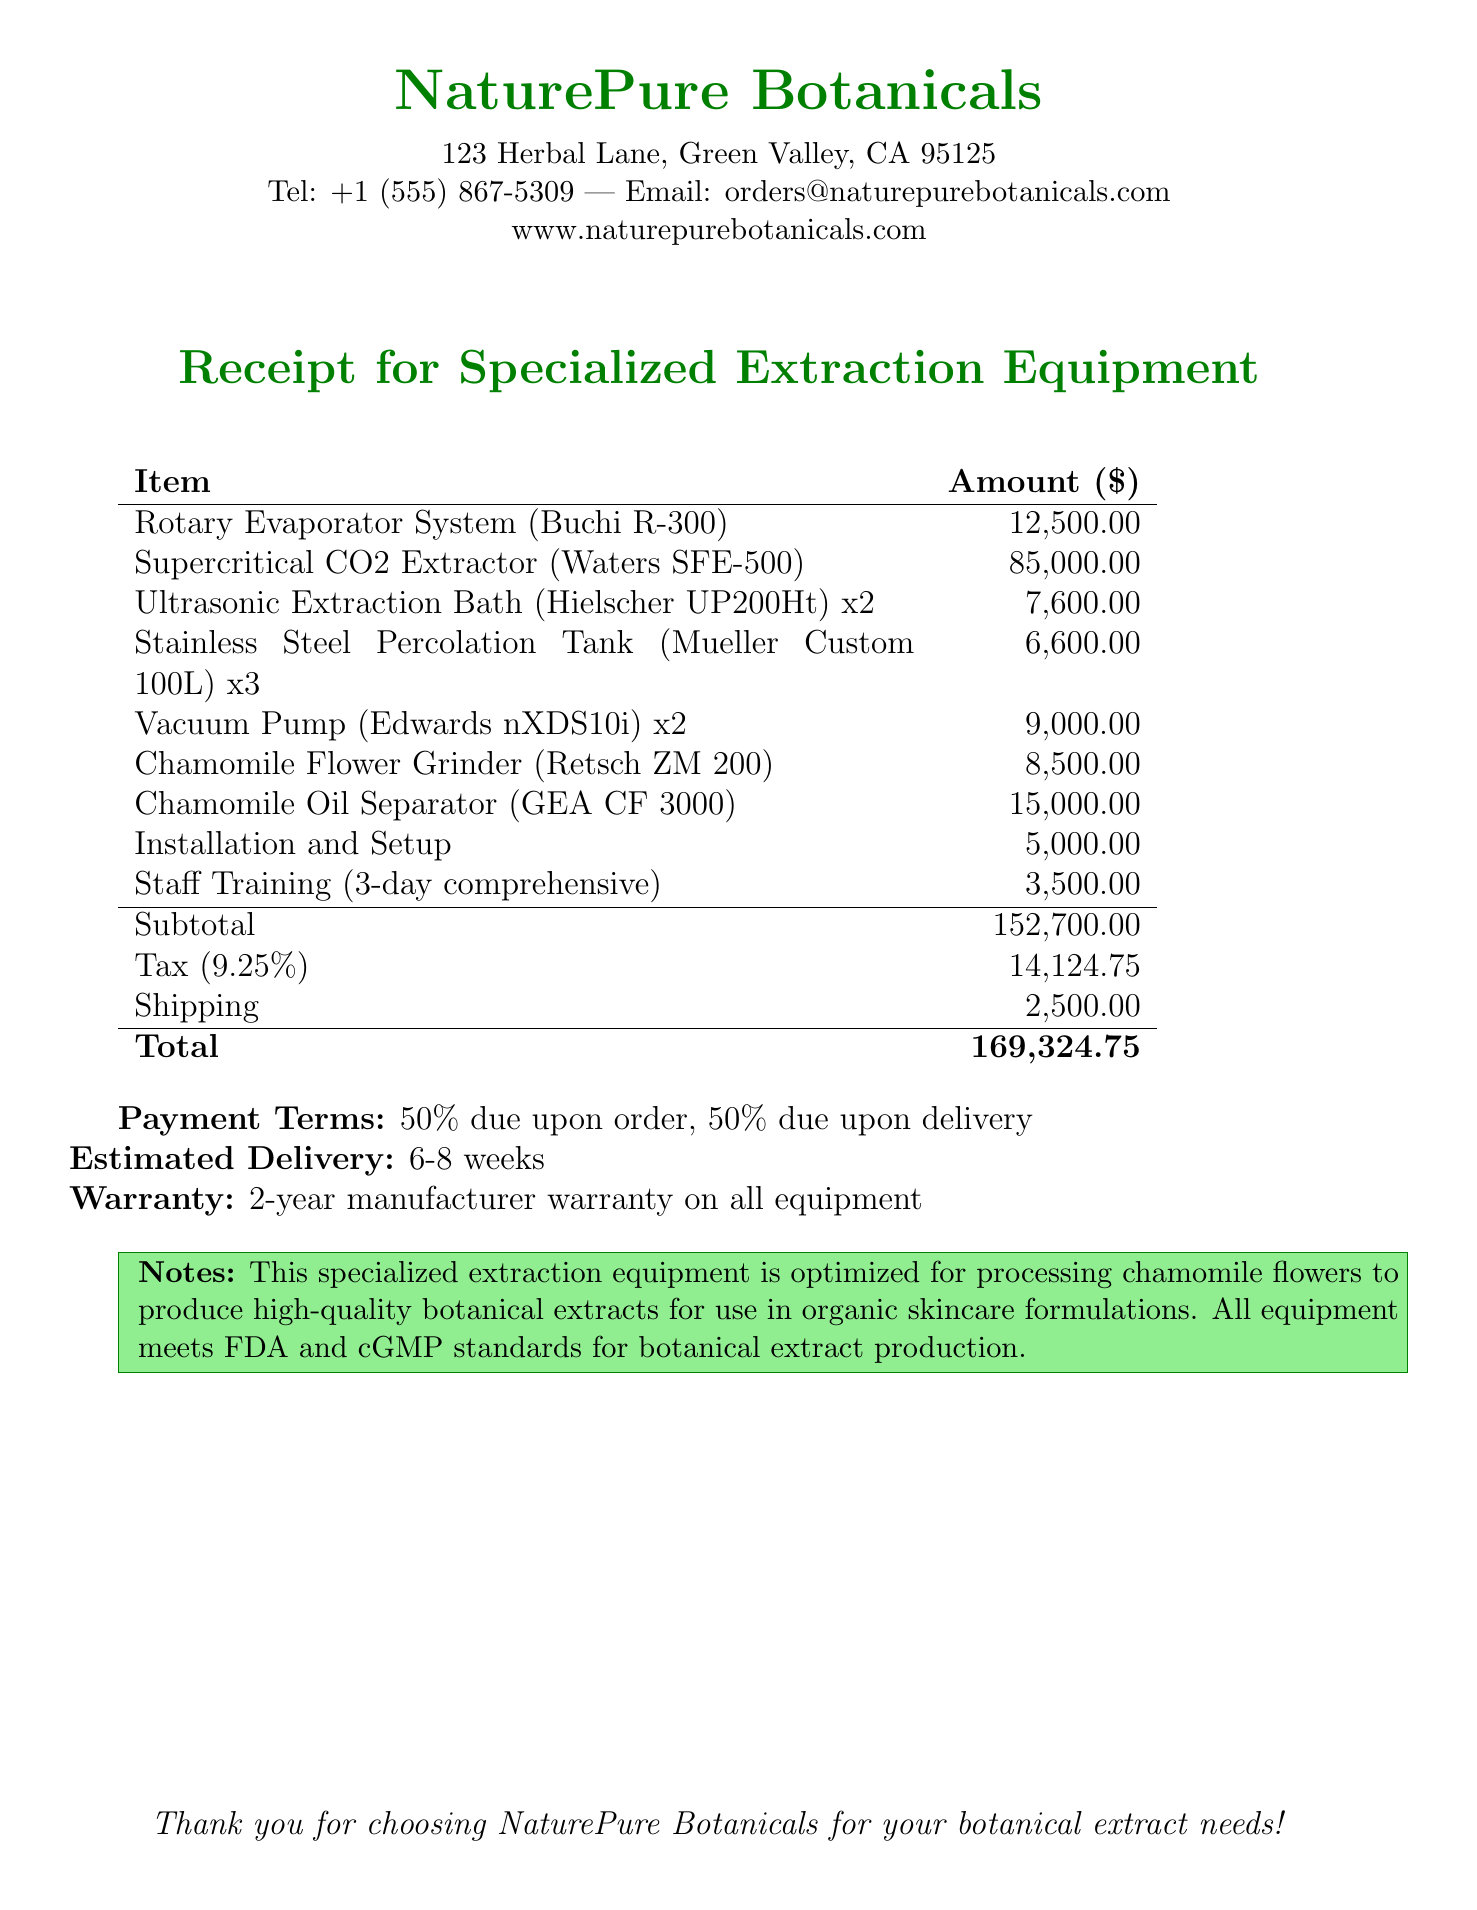What is the name of the company? The company name is provided at the top of the receipt.
Answer: NaturePure Botanicals What is the total amount due? The total amount is the final calculated sum at the bottom of the receipt.
Answer: 169,324.75 What is the warranty period for the equipment? The warranty information states the duration valid for the equipment purchased.
Answer: 2-year manufacturer warranty How many Ultrasonic Extraction Baths were purchased? The quantity of Ultrasonic Extraction Baths is listed under the purchase items.
Answer: 2 What is included in the installation service? The description of the installation service is provided in the additional services section.
Answer: Professional installation of all equipment What is the tax rate applied to the purchase? The tax rate is mentioned in the document, affecting the subtotal amount.
Answer: 9.25% How long is the estimated delivery time? The estimated delivery time is explicitly stated in the document.
Answer: 6-8 weeks What type of training is offered as an additional service? The training type is outlined in the additional services section of the document.
Answer: 3-day comprehensive training on equipment operation What item is the Chamomile Oil Separator? The Chamomile Oil Separator is listed under chamomile specific items with further details.
Answer: GEA CF 3000 